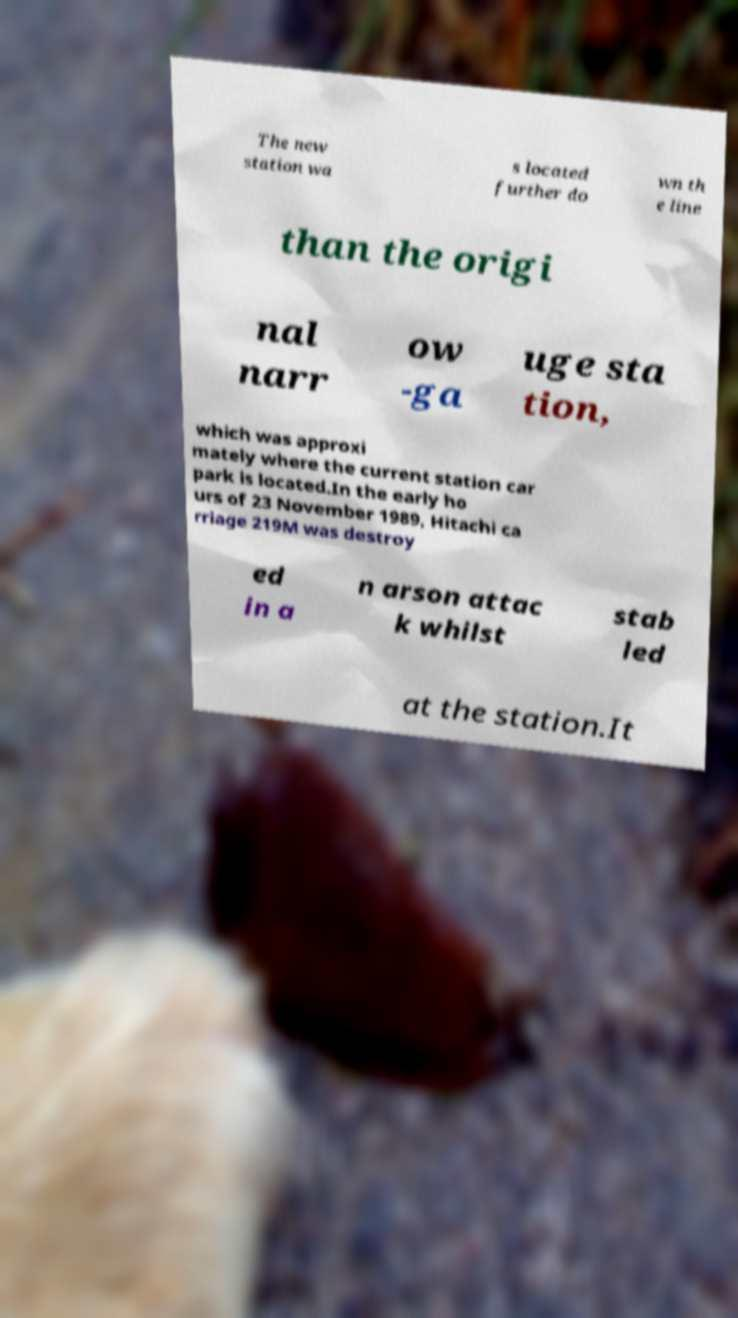Could you assist in decoding the text presented in this image and type it out clearly? The new station wa s located further do wn th e line than the origi nal narr ow -ga uge sta tion, which was approxi mately where the current station car park is located.In the early ho urs of 23 November 1989, Hitachi ca rriage 219M was destroy ed in a n arson attac k whilst stab led at the station.It 